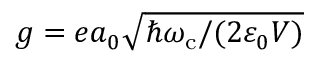<formula> <loc_0><loc_0><loc_500><loc_500>g = e a _ { 0 } \sqrt { \hbar { \omega } _ { c } / ( 2 \varepsilon _ { 0 } V ) }</formula> 